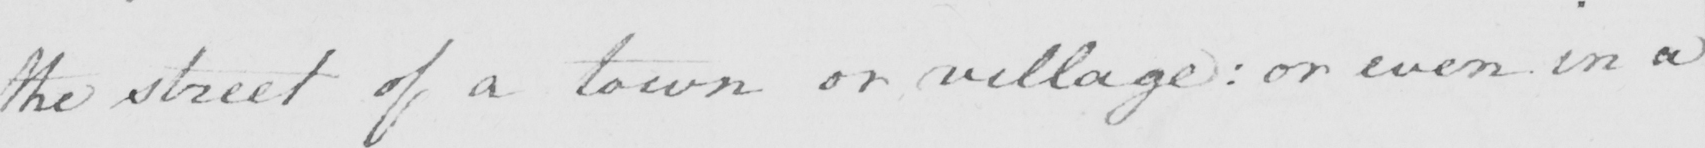What is written in this line of handwriting? the street of a town or village :  or even in a 